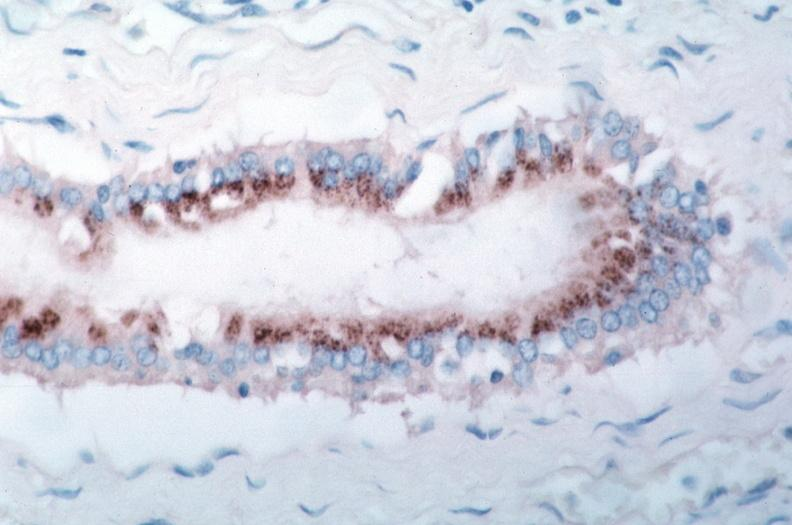what is present?
Answer the question using a single word or phrase. Cardiovascular 